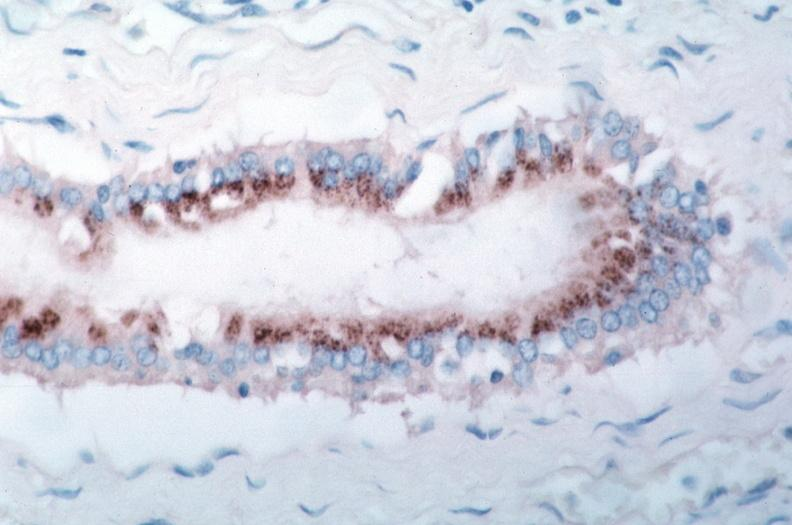what is present?
Answer the question using a single word or phrase. Cardiovascular 